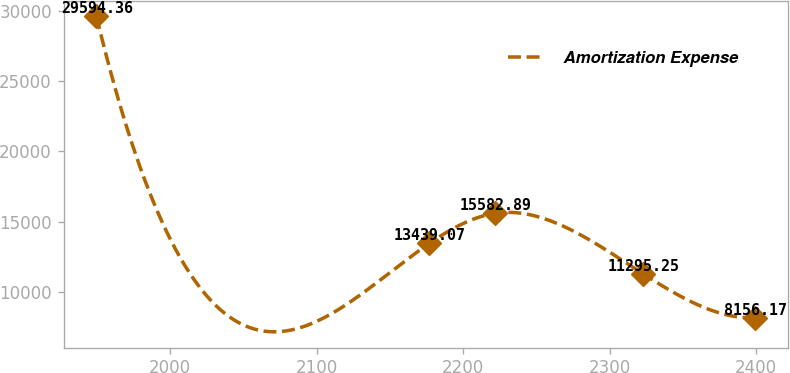<chart> <loc_0><loc_0><loc_500><loc_500><line_chart><ecel><fcel>Amortization Expense<nl><fcel>1949.63<fcel>29594.4<nl><fcel>2176.8<fcel>13439.1<nl><fcel>2221.76<fcel>15582.9<nl><fcel>2322.56<fcel>11295.2<nl><fcel>2399.26<fcel>8156.17<nl></chart> 